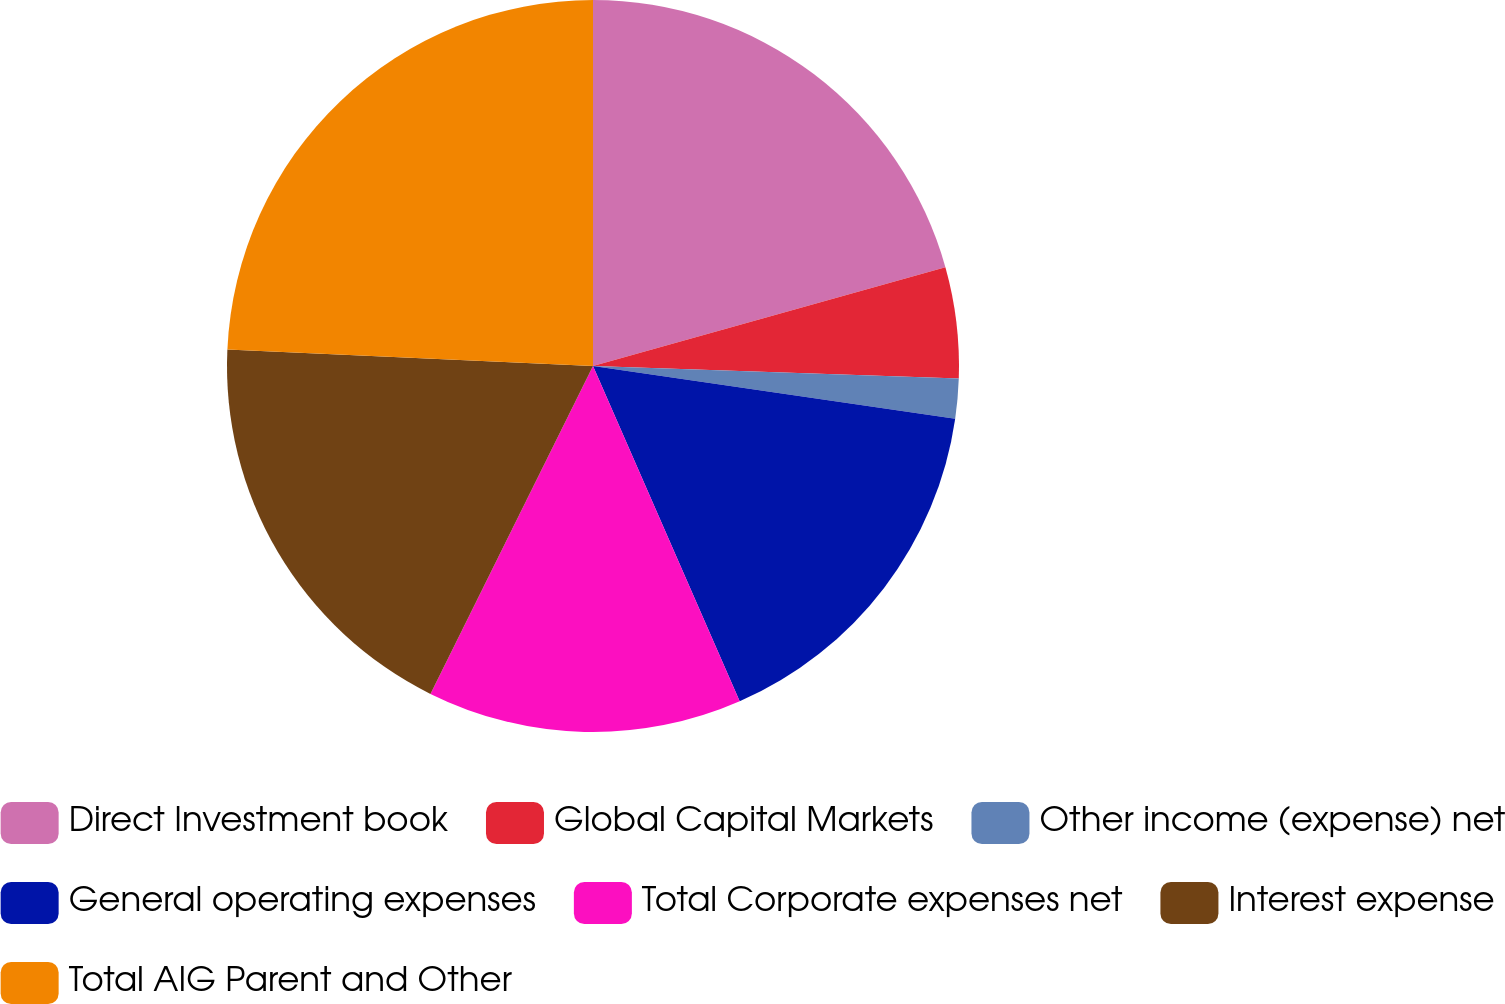<chart> <loc_0><loc_0><loc_500><loc_500><pie_chart><fcel>Direct Investment book<fcel>Global Capital Markets<fcel>Other income (expense) net<fcel>General operating expenses<fcel>Total Corporate expenses net<fcel>Interest expense<fcel>Total AIG Parent and Other<nl><fcel>20.65%<fcel>4.9%<fcel>1.75%<fcel>16.14%<fcel>13.89%<fcel>18.4%<fcel>24.28%<nl></chart> 